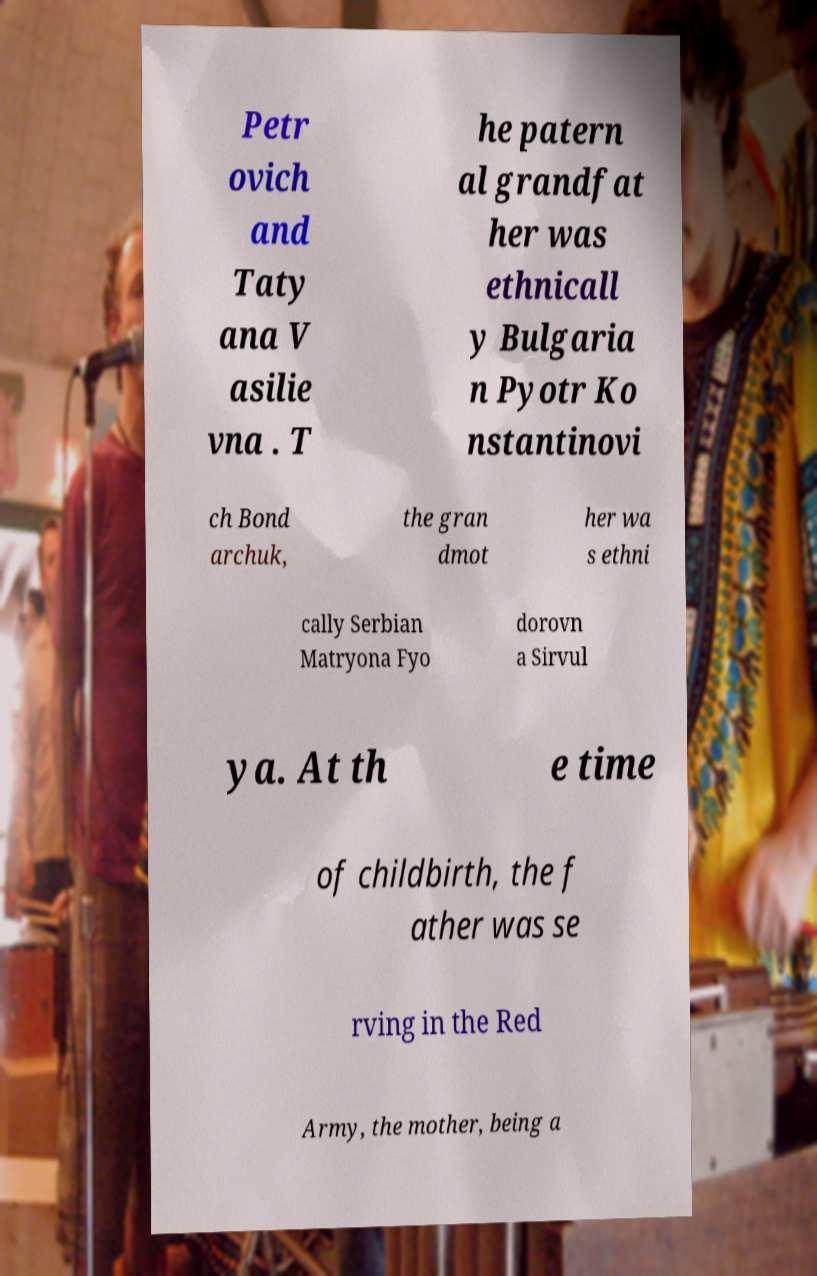Please identify and transcribe the text found in this image. Petr ovich and Taty ana V asilie vna . T he patern al grandfat her was ethnicall y Bulgaria n Pyotr Ko nstantinovi ch Bond archuk, the gran dmot her wa s ethni cally Serbian Matryona Fyo dorovn a Sirvul ya. At th e time of childbirth, the f ather was se rving in the Red Army, the mother, being a 